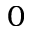Convert formula to latex. <formula><loc_0><loc_0><loc_500><loc_500>0</formula> 